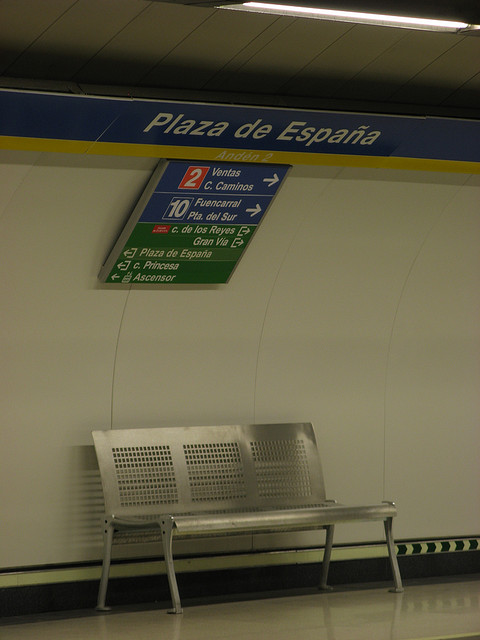What is the name of the place shown in the sign above the bench? The sign above the bench indicates 'Plaza de España', suggesting this location is likely a metro or train station named after the square.  Can you tell me the color of the walls in this image? The walls in the image are primarily white, which helps in reflecting the available light, giving a brighter appearance to the station. 